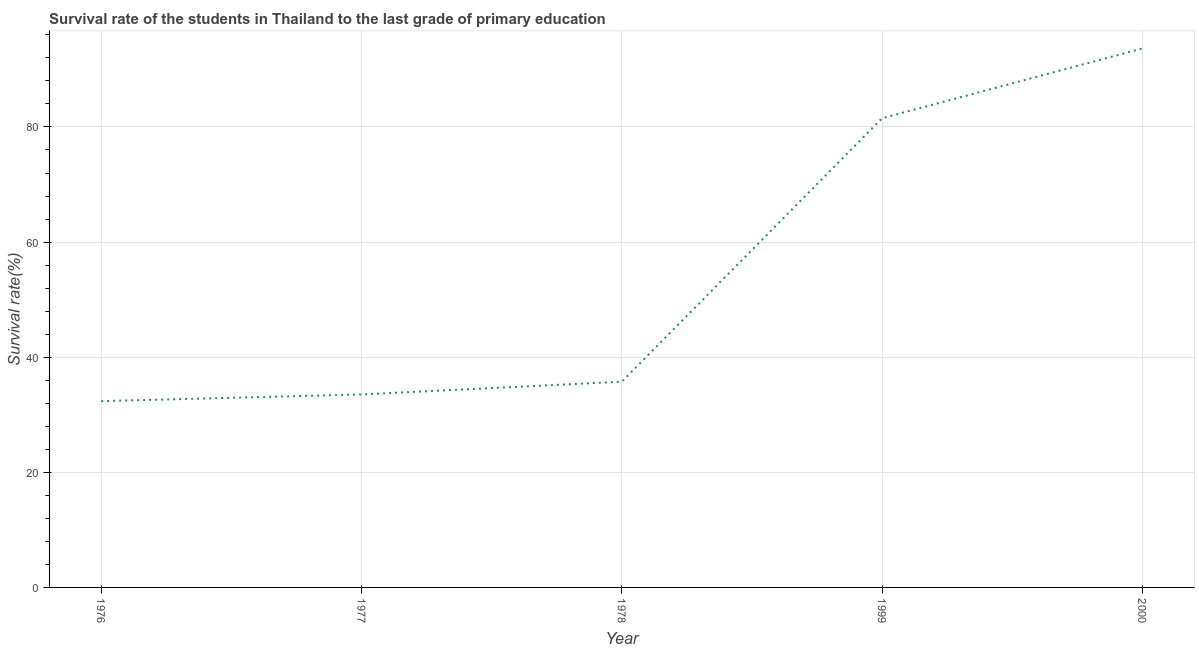What is the survival rate in primary education in 1977?
Your answer should be compact. 33.53. Across all years, what is the maximum survival rate in primary education?
Your response must be concise. 93.64. Across all years, what is the minimum survival rate in primary education?
Your response must be concise. 32.37. In which year was the survival rate in primary education minimum?
Keep it short and to the point. 1976. What is the sum of the survival rate in primary education?
Offer a very short reply. 276.8. What is the difference between the survival rate in primary education in 1976 and 1978?
Your answer should be compact. -3.38. What is the average survival rate in primary education per year?
Your answer should be compact. 55.36. What is the median survival rate in primary education?
Provide a succinct answer. 35.75. In how many years, is the survival rate in primary education greater than 24 %?
Your answer should be very brief. 5. Do a majority of the years between 2000 and 1978 (inclusive) have survival rate in primary education greater than 44 %?
Ensure brevity in your answer.  No. What is the ratio of the survival rate in primary education in 1977 to that in 2000?
Keep it short and to the point. 0.36. Is the survival rate in primary education in 1976 less than that in 1999?
Provide a succinct answer. Yes. Is the difference between the survival rate in primary education in 1976 and 1999 greater than the difference between any two years?
Offer a terse response. No. What is the difference between the highest and the second highest survival rate in primary education?
Provide a succinct answer. 12.12. What is the difference between the highest and the lowest survival rate in primary education?
Your response must be concise. 61.27. Does the survival rate in primary education monotonically increase over the years?
Provide a succinct answer. Yes. How many lines are there?
Offer a terse response. 1. Are the values on the major ticks of Y-axis written in scientific E-notation?
Provide a succinct answer. No. Does the graph contain any zero values?
Your answer should be very brief. No. What is the title of the graph?
Provide a short and direct response. Survival rate of the students in Thailand to the last grade of primary education. What is the label or title of the Y-axis?
Your response must be concise. Survival rate(%). What is the Survival rate(%) in 1976?
Make the answer very short. 32.37. What is the Survival rate(%) of 1977?
Keep it short and to the point. 33.53. What is the Survival rate(%) in 1978?
Ensure brevity in your answer.  35.75. What is the Survival rate(%) of 1999?
Offer a terse response. 81.52. What is the Survival rate(%) of 2000?
Offer a very short reply. 93.64. What is the difference between the Survival rate(%) in 1976 and 1977?
Give a very brief answer. -1.16. What is the difference between the Survival rate(%) in 1976 and 1978?
Keep it short and to the point. -3.38. What is the difference between the Survival rate(%) in 1976 and 1999?
Provide a succinct answer. -49.15. What is the difference between the Survival rate(%) in 1976 and 2000?
Keep it short and to the point. -61.27. What is the difference between the Survival rate(%) in 1977 and 1978?
Provide a succinct answer. -2.22. What is the difference between the Survival rate(%) in 1977 and 1999?
Provide a short and direct response. -47.99. What is the difference between the Survival rate(%) in 1977 and 2000?
Ensure brevity in your answer.  -60.11. What is the difference between the Survival rate(%) in 1978 and 1999?
Offer a terse response. -45.77. What is the difference between the Survival rate(%) in 1978 and 2000?
Make the answer very short. -57.89. What is the difference between the Survival rate(%) in 1999 and 2000?
Ensure brevity in your answer.  -12.12. What is the ratio of the Survival rate(%) in 1976 to that in 1978?
Your answer should be compact. 0.91. What is the ratio of the Survival rate(%) in 1976 to that in 1999?
Offer a terse response. 0.4. What is the ratio of the Survival rate(%) in 1976 to that in 2000?
Ensure brevity in your answer.  0.35. What is the ratio of the Survival rate(%) in 1977 to that in 1978?
Offer a very short reply. 0.94. What is the ratio of the Survival rate(%) in 1977 to that in 1999?
Your answer should be very brief. 0.41. What is the ratio of the Survival rate(%) in 1977 to that in 2000?
Ensure brevity in your answer.  0.36. What is the ratio of the Survival rate(%) in 1978 to that in 1999?
Offer a terse response. 0.44. What is the ratio of the Survival rate(%) in 1978 to that in 2000?
Offer a very short reply. 0.38. What is the ratio of the Survival rate(%) in 1999 to that in 2000?
Offer a very short reply. 0.87. 